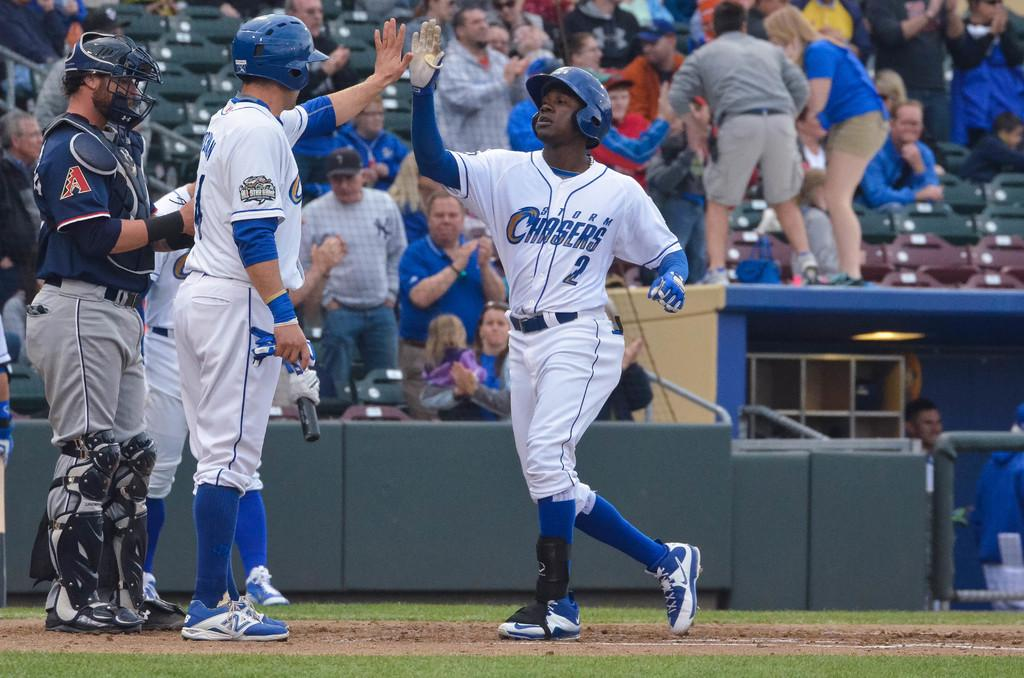<image>
Describe the image concisely. Number 2 of the Storm Chasers is high fiving his teammate. 